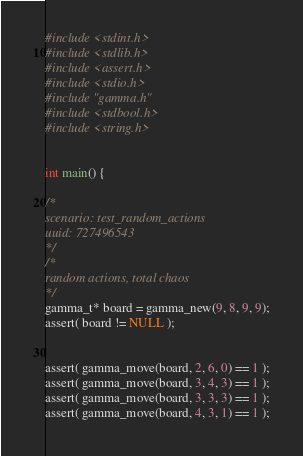<code> <loc_0><loc_0><loc_500><loc_500><_C_>#include <stdint.h>
#include <stdlib.h>
#include <assert.h>
#include <stdio.h>
#include "gamma.h"
#include <stdbool.h>
#include <string.h>


int main() {

/*
scenario: test_random_actions
uuid: 727496543
*/
/*
random actions, total chaos
*/
gamma_t* board = gamma_new(9, 8, 9, 9);
assert( board != NULL );


assert( gamma_move(board, 2, 6, 0) == 1 );
assert( gamma_move(board, 3, 4, 3) == 1 );
assert( gamma_move(board, 3, 3, 3) == 1 );
assert( gamma_move(board, 4, 3, 1) == 1 );</code> 